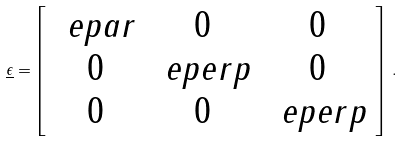Convert formula to latex. <formula><loc_0><loc_0><loc_500><loc_500>\underline { \epsilon } = \left [ \begin{array} { c c c } \ e p a r & 0 & 0 \\ 0 & \ e p e r p & 0 \\ 0 & 0 & \ e p e r p \end{array} \right ] \, .</formula> 